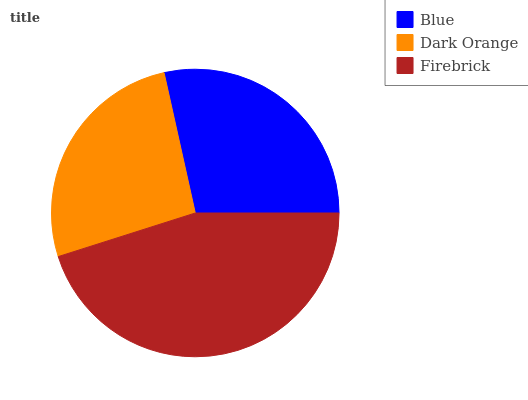Is Dark Orange the minimum?
Answer yes or no. Yes. Is Firebrick the maximum?
Answer yes or no. Yes. Is Firebrick the minimum?
Answer yes or no. No. Is Dark Orange the maximum?
Answer yes or no. No. Is Firebrick greater than Dark Orange?
Answer yes or no. Yes. Is Dark Orange less than Firebrick?
Answer yes or no. Yes. Is Dark Orange greater than Firebrick?
Answer yes or no. No. Is Firebrick less than Dark Orange?
Answer yes or no. No. Is Blue the high median?
Answer yes or no. Yes. Is Blue the low median?
Answer yes or no. Yes. Is Firebrick the high median?
Answer yes or no. No. Is Firebrick the low median?
Answer yes or no. No. 